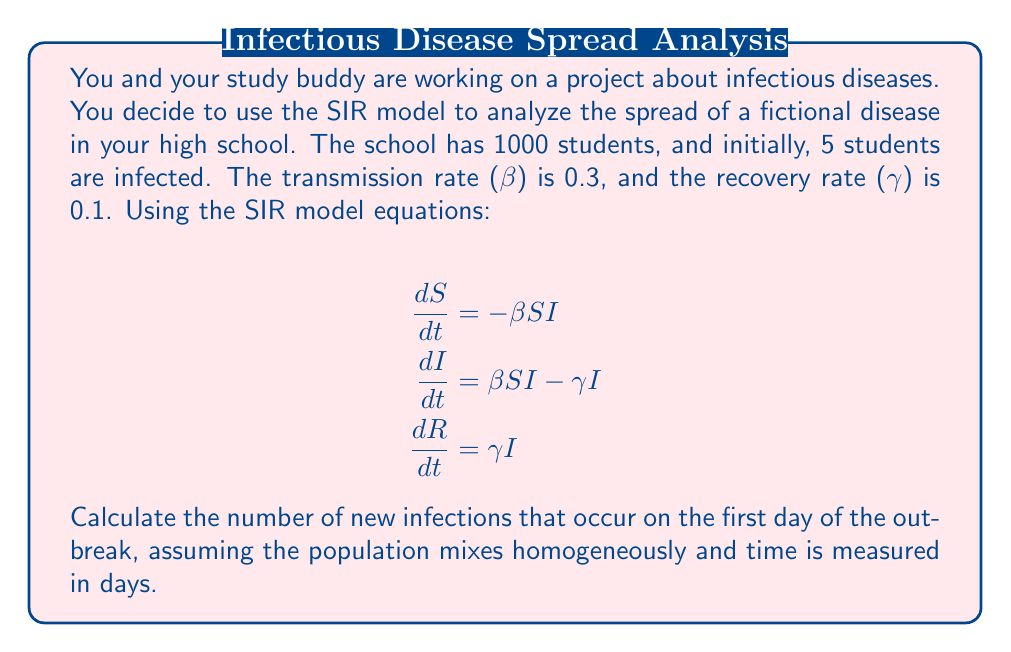Provide a solution to this math problem. Let's approach this step-by-step:

1) First, we need to identify our initial values:
   - Total population: N = 1000
   - Initially infected: I₀ = 5
   - Initially susceptible: S₀ = N - I₀ = 1000 - 5 = 995
   - Transmission rate: β = 0.3
   - Recovery rate: γ = 0.1

2) We're interested in new infections, which is represented by the rate of change of infected individuals (dI/dt) minus the recovery rate.

3) From the SIR model, we have:
   $$\frac{dI}{dt} = \beta SI - \gamma I$$

4) To find new infections only, we use:
   New infections = $\beta SI$

5) Plugging in our values:
   New infections = $0.3 * 995 * 5 = 1492.5$

6) However, this is the rate per day. To find the actual number of new infections in one day, we need to consider that as people get infected, they're no longer susceptible. A simple approximation is to use the average of the initial and final susceptible population over the day.

7) We can estimate the susceptible population at the end of the day:
   $S_1 \approx S_0 - \text{New infections} = 995 - 1492.5 = -497.5$

   But S can't be negative, so we'll use 0.

8) Now we can use the average:
   Average S = $(995 + 0) / 2 = 497.5$

9) Recalculating:
   New infections = $0.3 * 497.5 * 5 = 746.25$

10) Since we can't have fractional infections, we round to the nearest whole number.
Answer: 746 new infections 